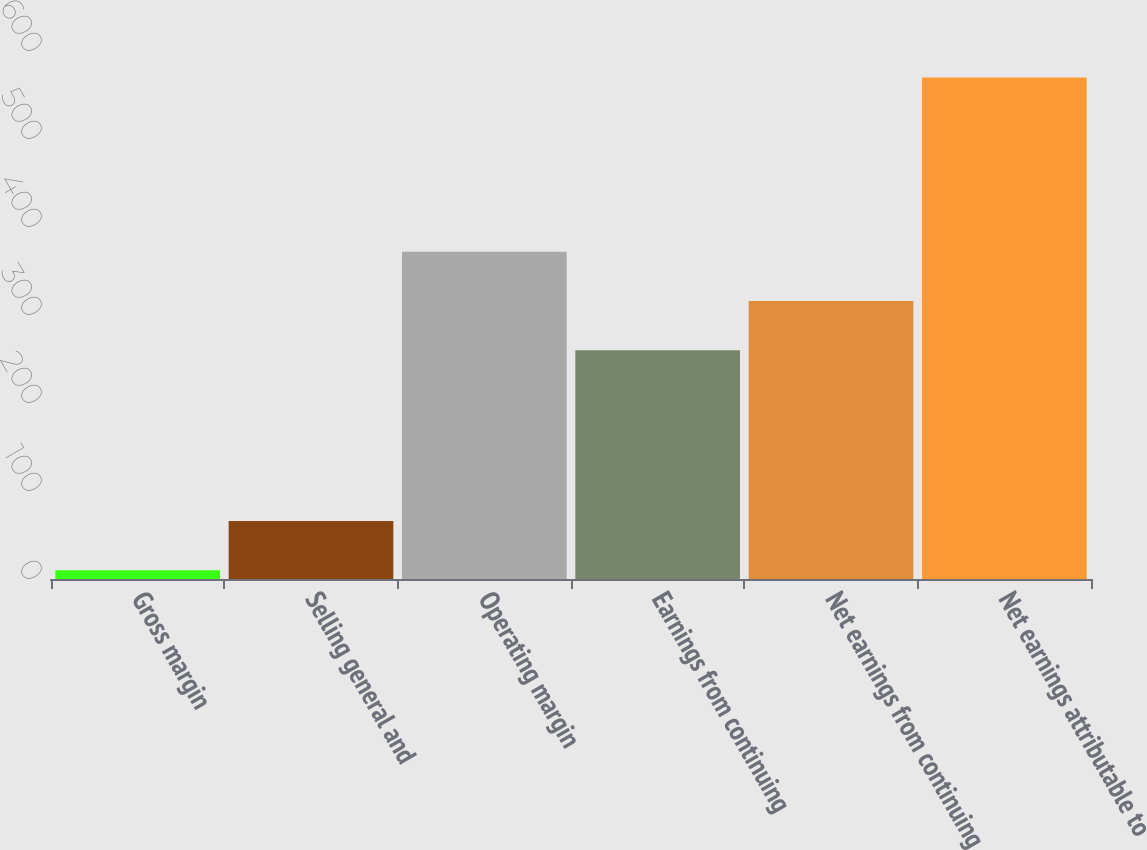Convert chart. <chart><loc_0><loc_0><loc_500><loc_500><bar_chart><fcel>Gross margin<fcel>Selling general and<fcel>Operating margin<fcel>Earnings from continuing<fcel>Net earnings from continuing<fcel>Net earnings attributable to<nl><fcel>10<fcel>66<fcel>372<fcel>260<fcel>316<fcel>570<nl></chart> 